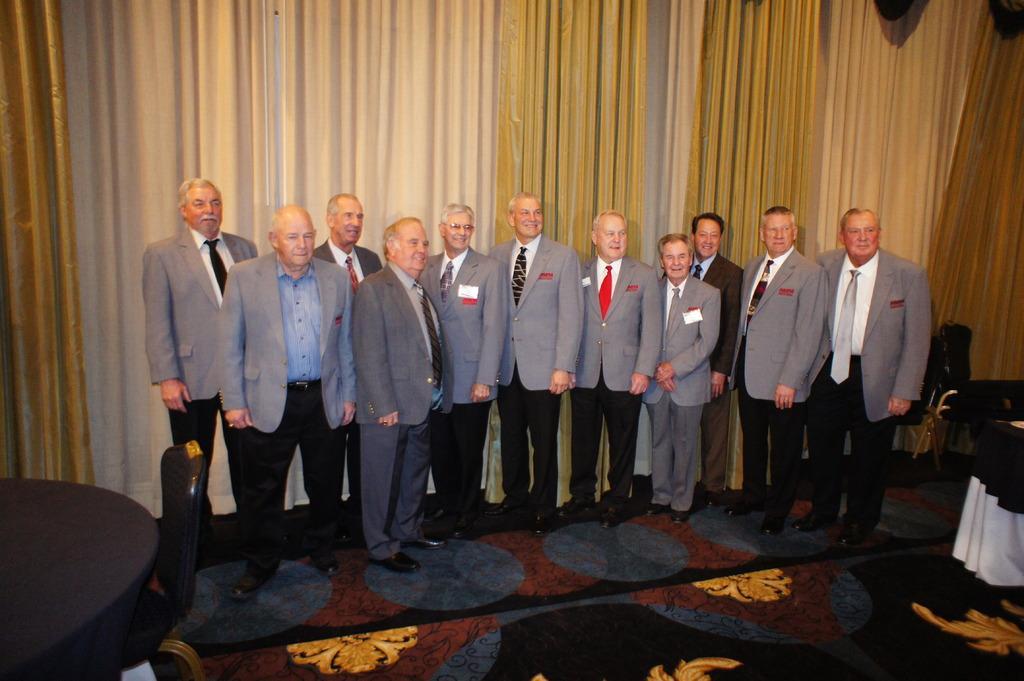How would you summarize this image in a sentence or two? In this picture we can see a group of people, tables and chairs on the ground and in the background we can see curtains. 